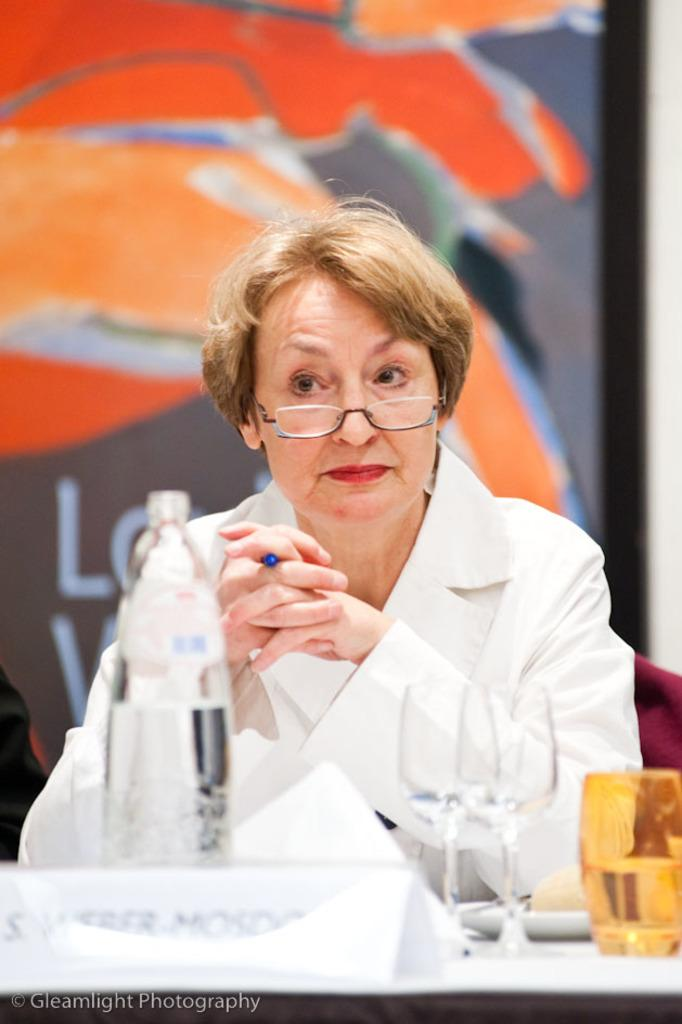What is the main subject of the image? There is a woman in the image. Can you describe what the woman is wearing? The woman is wearing a white jacket. Where is the woman sitting in the image? The woman is sitting in front of a table. What items can be seen on the table? There is a water bottle and glasses on the table. What is visible behind the woman? There is a wall behind the woman. Can you describe anything on the wall? There is a painting on the wall. What type of engine can be seen in the image? There is no engine present in the image. Can you describe the road in the image? There is no road present in the image. 